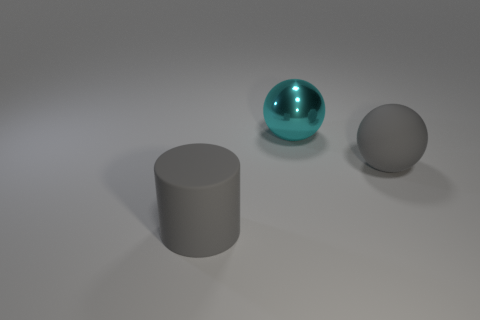What number of large things are the same color as the large rubber ball?
Make the answer very short. 1. What is the size of the object that is in front of the metal ball and on the right side of the big gray matte cylinder?
Keep it short and to the point. Large. Is the number of large gray rubber things behind the metal ball less than the number of purple metal objects?
Give a very brief answer. No. Is the material of the cylinder the same as the large cyan thing?
Ensure brevity in your answer.  No. What number of things are big gray things or spheres?
Your answer should be very brief. 3. What number of large gray spheres have the same material as the big gray cylinder?
Give a very brief answer. 1. The gray thing that is the same shape as the big cyan object is what size?
Your answer should be very brief. Large. There is a large rubber sphere; are there any big gray balls to the right of it?
Offer a very short reply. No. What is the material of the big gray cylinder?
Offer a terse response. Rubber. Is the color of the matte thing right of the big gray cylinder the same as the cylinder?
Your answer should be compact. Yes. 